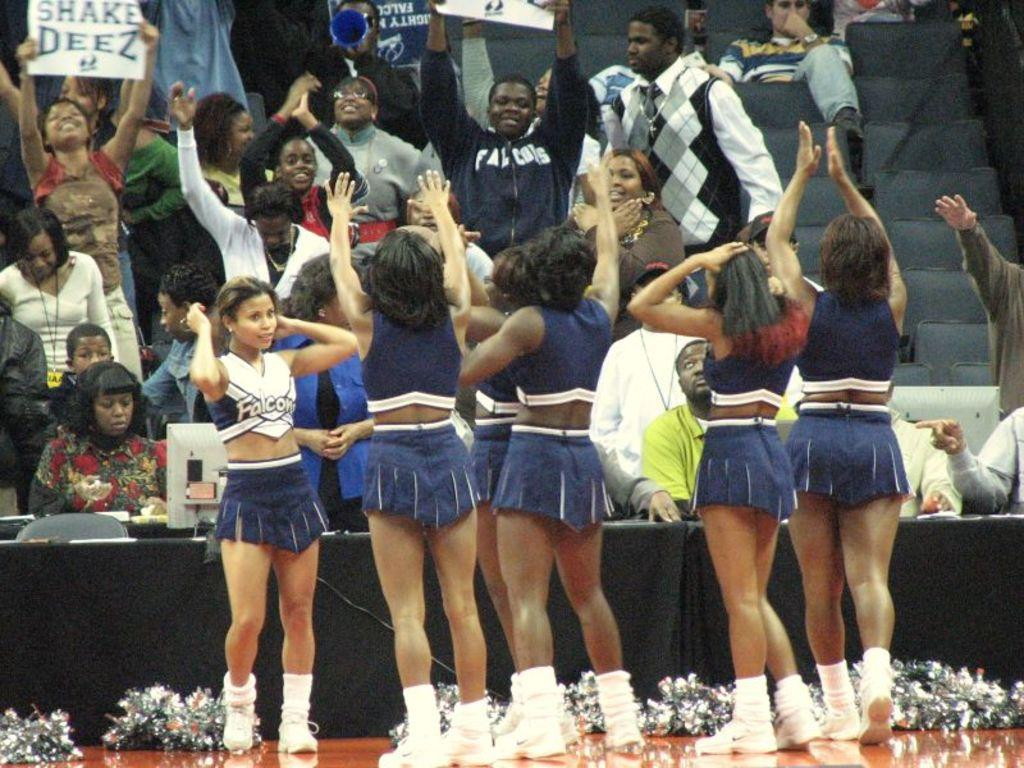<image>
Offer a succinct explanation of the picture presented. Five cheerleaders stand in front of a crowd, in which there are people holding up signs, such as "Shake Deez" 